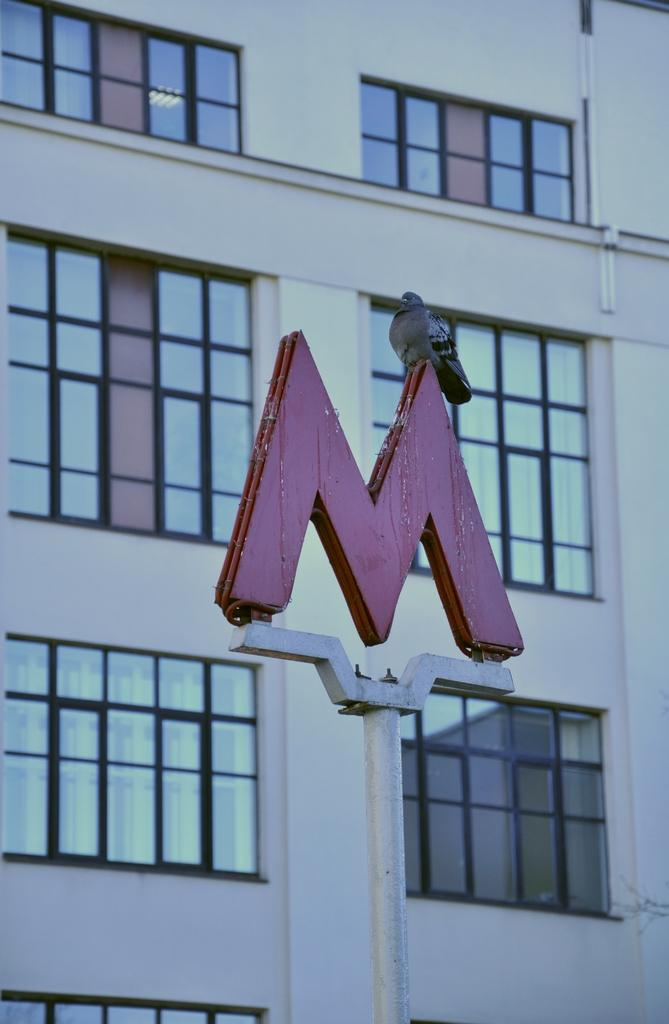What is the main object in the image? There is a pole in the image. What is written on the pole? The pole has a letter 'M' on it. What type of animal can be seen in the image? There is a bird in the image. What can be seen in the background of the image? There is a building in the background of the image. How many windows are visible on the building? The building has many windows. What type of insect can be seen flying around the bird in the image? There is no insect visible in the image; only a bird is present. 